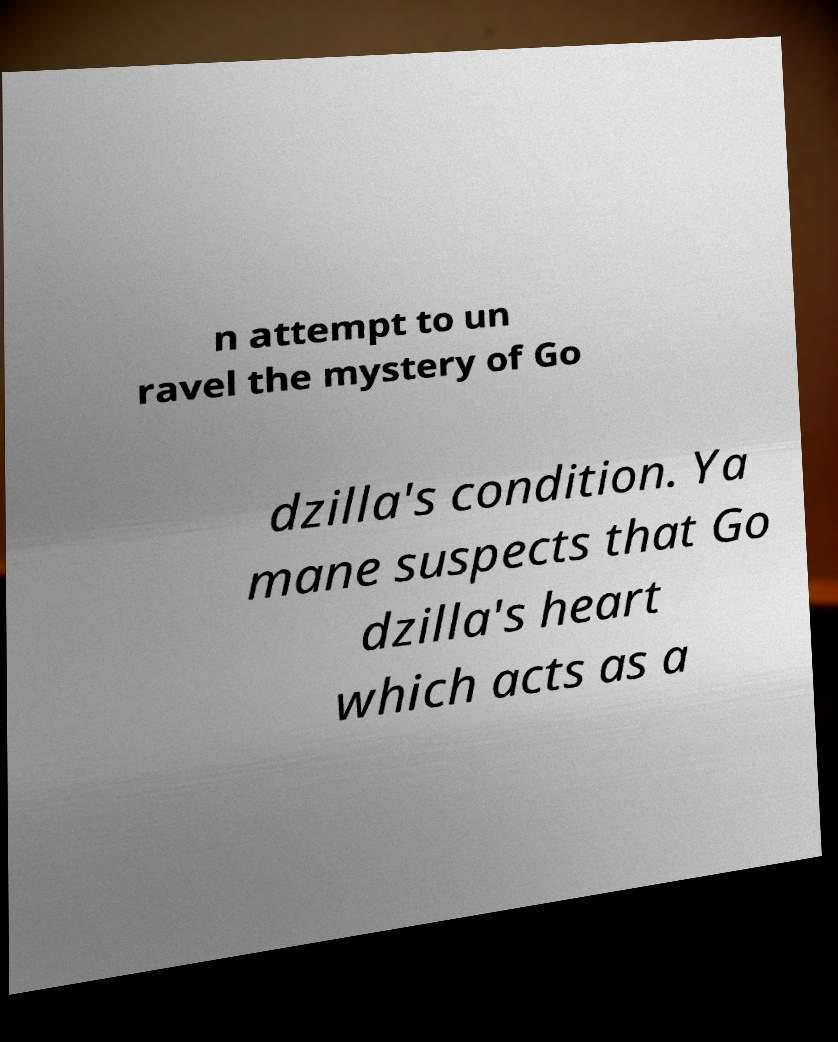Could you extract and type out the text from this image? n attempt to un ravel the mystery of Go dzilla's condition. Ya mane suspects that Go dzilla's heart which acts as a 